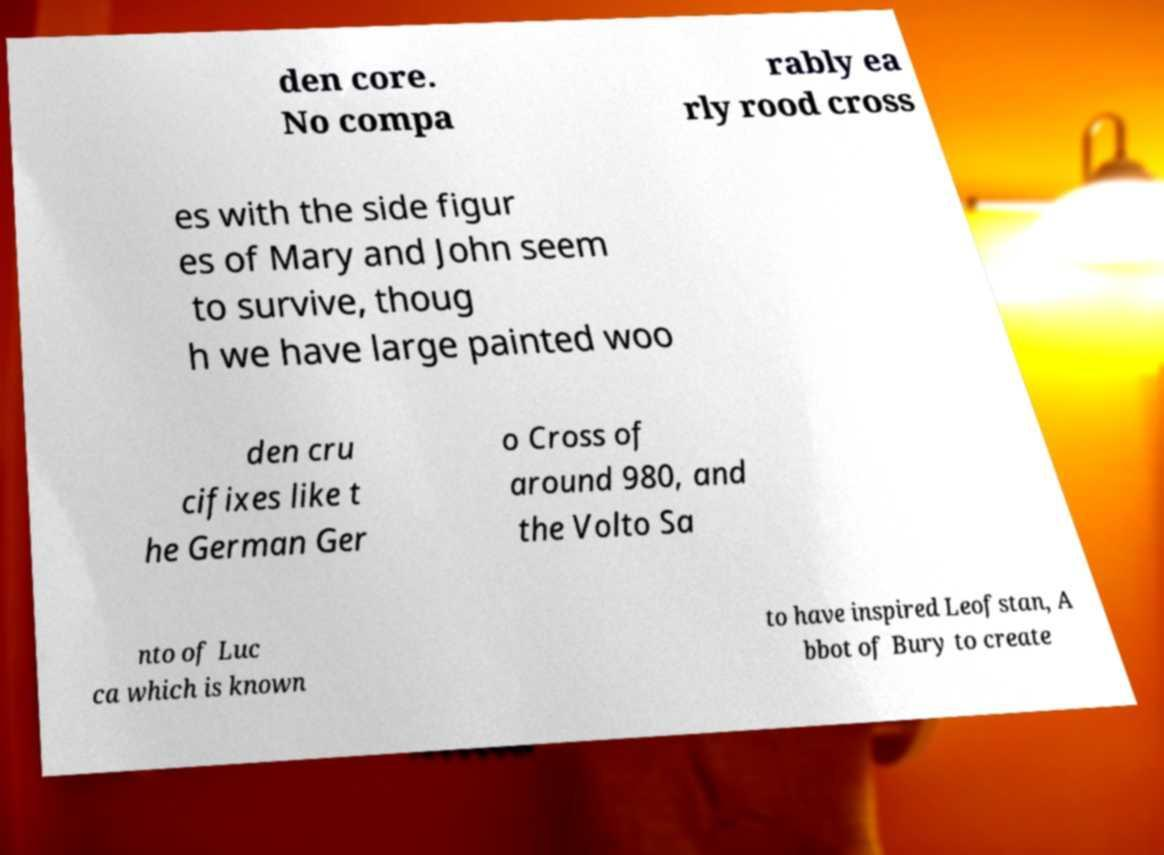I need the written content from this picture converted into text. Can you do that? den core. No compa rably ea rly rood cross es with the side figur es of Mary and John seem to survive, thoug h we have large painted woo den cru cifixes like t he German Ger o Cross of around 980, and the Volto Sa nto of Luc ca which is known to have inspired Leofstan, A bbot of Bury to create 